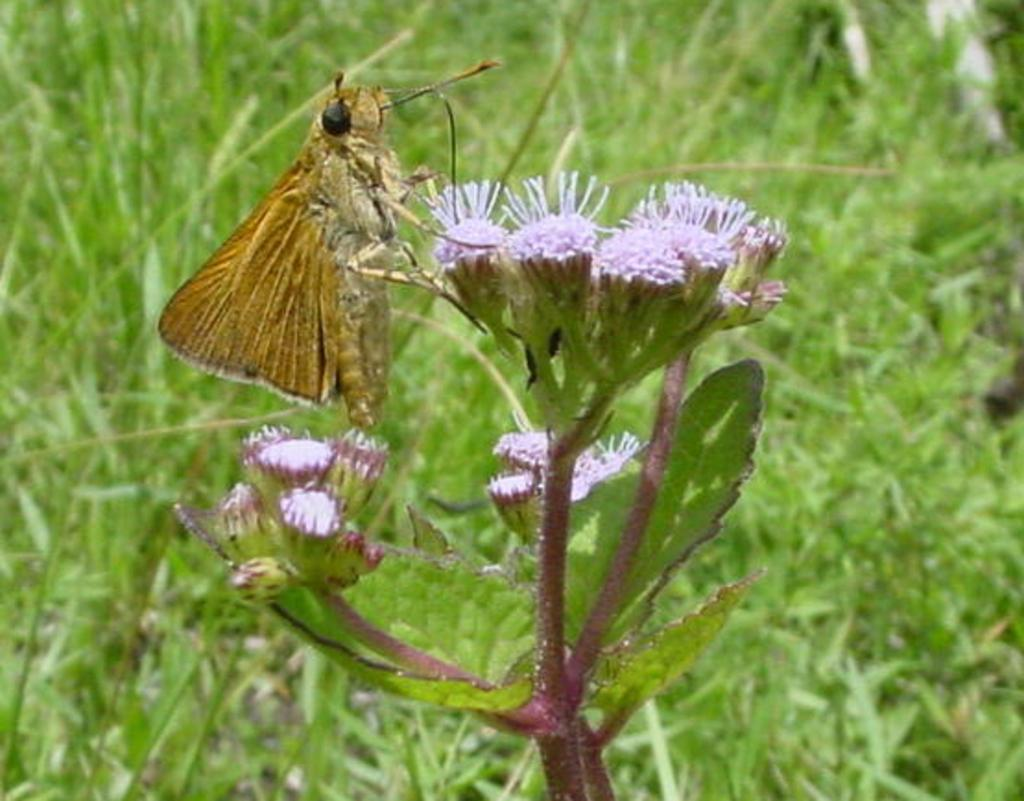What is on the flower in the image? There is a fly on a flower in the image. What can be seen in the background of the image? There is grass visible in the background of the image. What type of reward is being given to the protestors in the image? There is no protest or reward present in the image; it features a fly on a flower and grass in the background. 